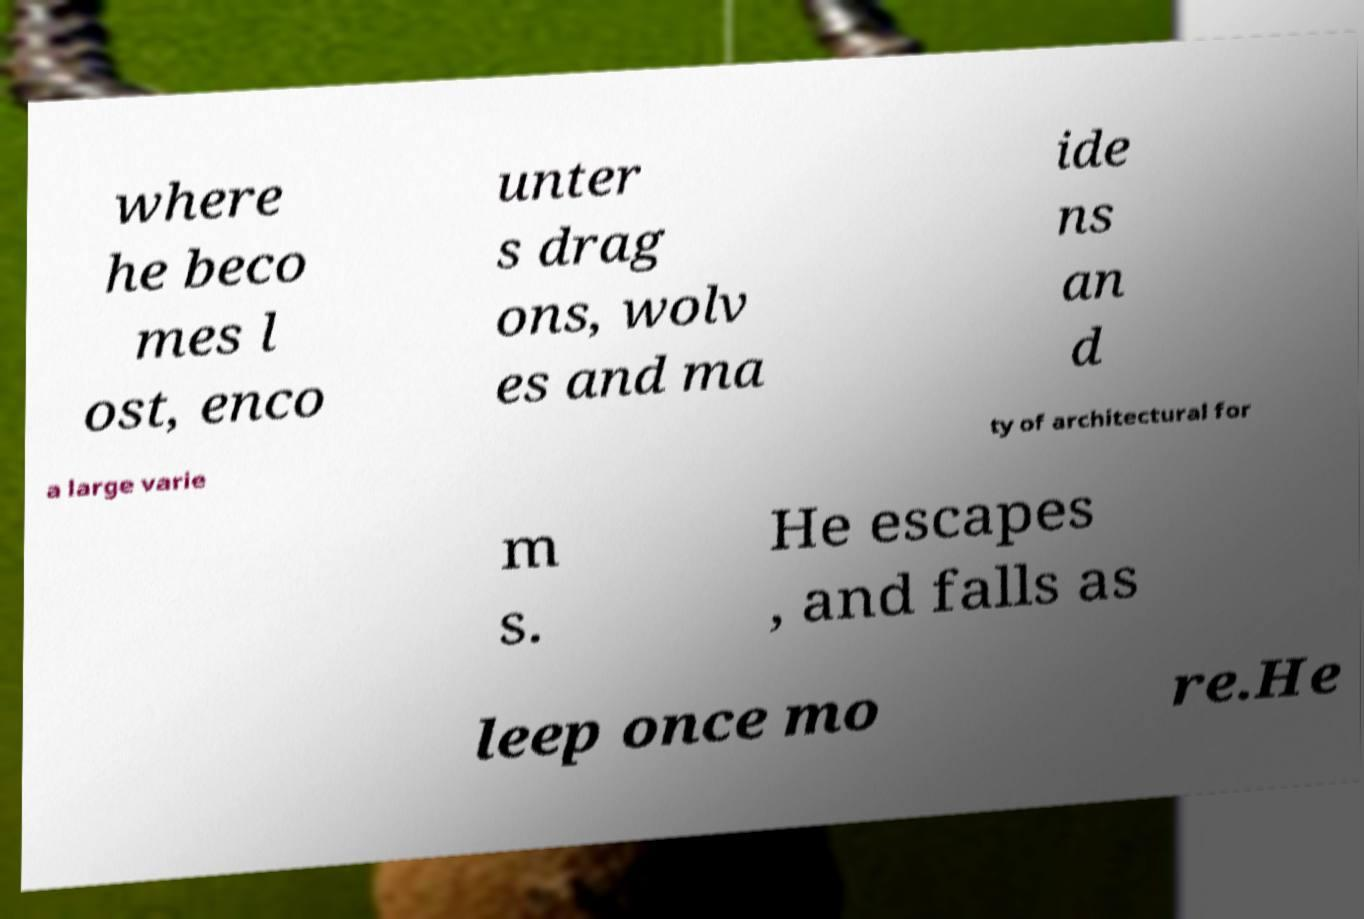There's text embedded in this image that I need extracted. Can you transcribe it verbatim? where he beco mes l ost, enco unter s drag ons, wolv es and ma ide ns an d a large varie ty of architectural for m s. He escapes , and falls as leep once mo re.He 